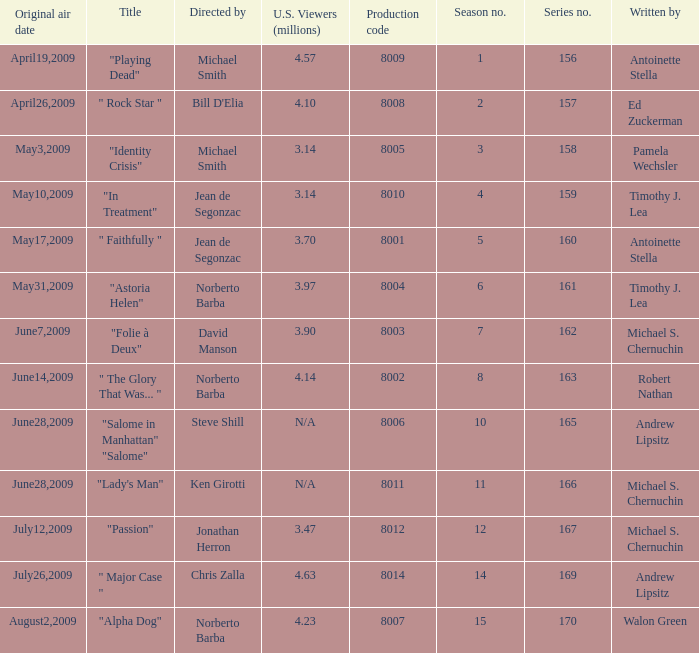How many writers write the episode whose director is Jonathan Herron? 1.0. 